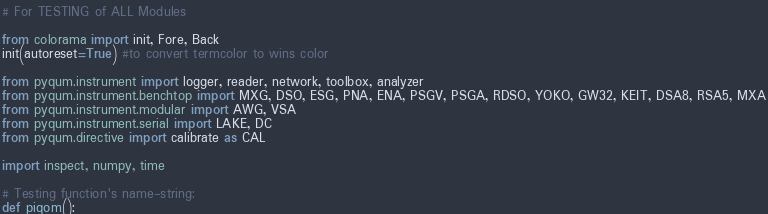<code> <loc_0><loc_0><loc_500><loc_500><_Python_># For TESTING of ALL Modules

from colorama import init, Fore, Back
init(autoreset=True) #to convert termcolor to wins color

from pyqum.instrument import logger, reader, network, toolbox, analyzer
from pyqum.instrument.benchtop import MXG, DSO, ESG, PNA, ENA, PSGV, PSGA, RDSO, YOKO, GW32, KEIT, DSA8, RSA5, MXA
from pyqum.instrument.modular import AWG, VSA
from pyqum.instrument.serial import LAKE, DC
from pyqum.directive import calibrate as CAL

import inspect, numpy, time

# Testing function's name-string:
def piqom():</code> 